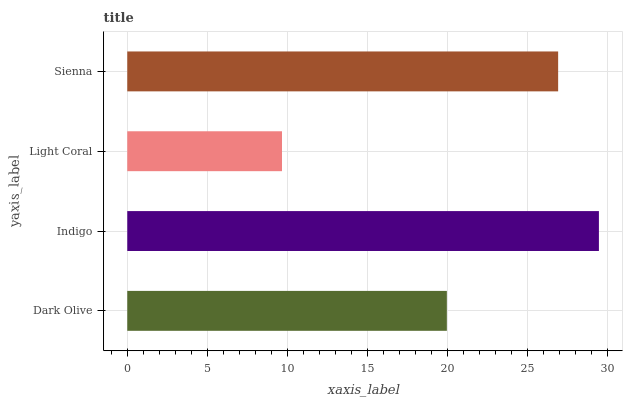Is Light Coral the minimum?
Answer yes or no. Yes. Is Indigo the maximum?
Answer yes or no. Yes. Is Indigo the minimum?
Answer yes or no. No. Is Light Coral the maximum?
Answer yes or no. No. Is Indigo greater than Light Coral?
Answer yes or no. Yes. Is Light Coral less than Indigo?
Answer yes or no. Yes. Is Light Coral greater than Indigo?
Answer yes or no. No. Is Indigo less than Light Coral?
Answer yes or no. No. Is Sienna the high median?
Answer yes or no. Yes. Is Dark Olive the low median?
Answer yes or no. Yes. Is Indigo the high median?
Answer yes or no. No. Is Light Coral the low median?
Answer yes or no. No. 